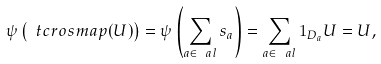Convert formula to latex. <formula><loc_0><loc_0><loc_500><loc_500>\psi \left ( \ t c r o s m a p ( U ) \right ) = \psi \left ( \sum _ { a \in \ a l } s _ { a } \right ) = \sum _ { a \in \ a l } 1 _ { D _ { a } } U = U ,</formula> 